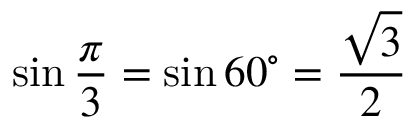<formula> <loc_0><loc_0><loc_500><loc_500>\sin { \frac { \pi } { 3 } } = \sin 6 0 ^ { \circ } = { \frac { \sqrt { 3 } } { 2 } }</formula> 